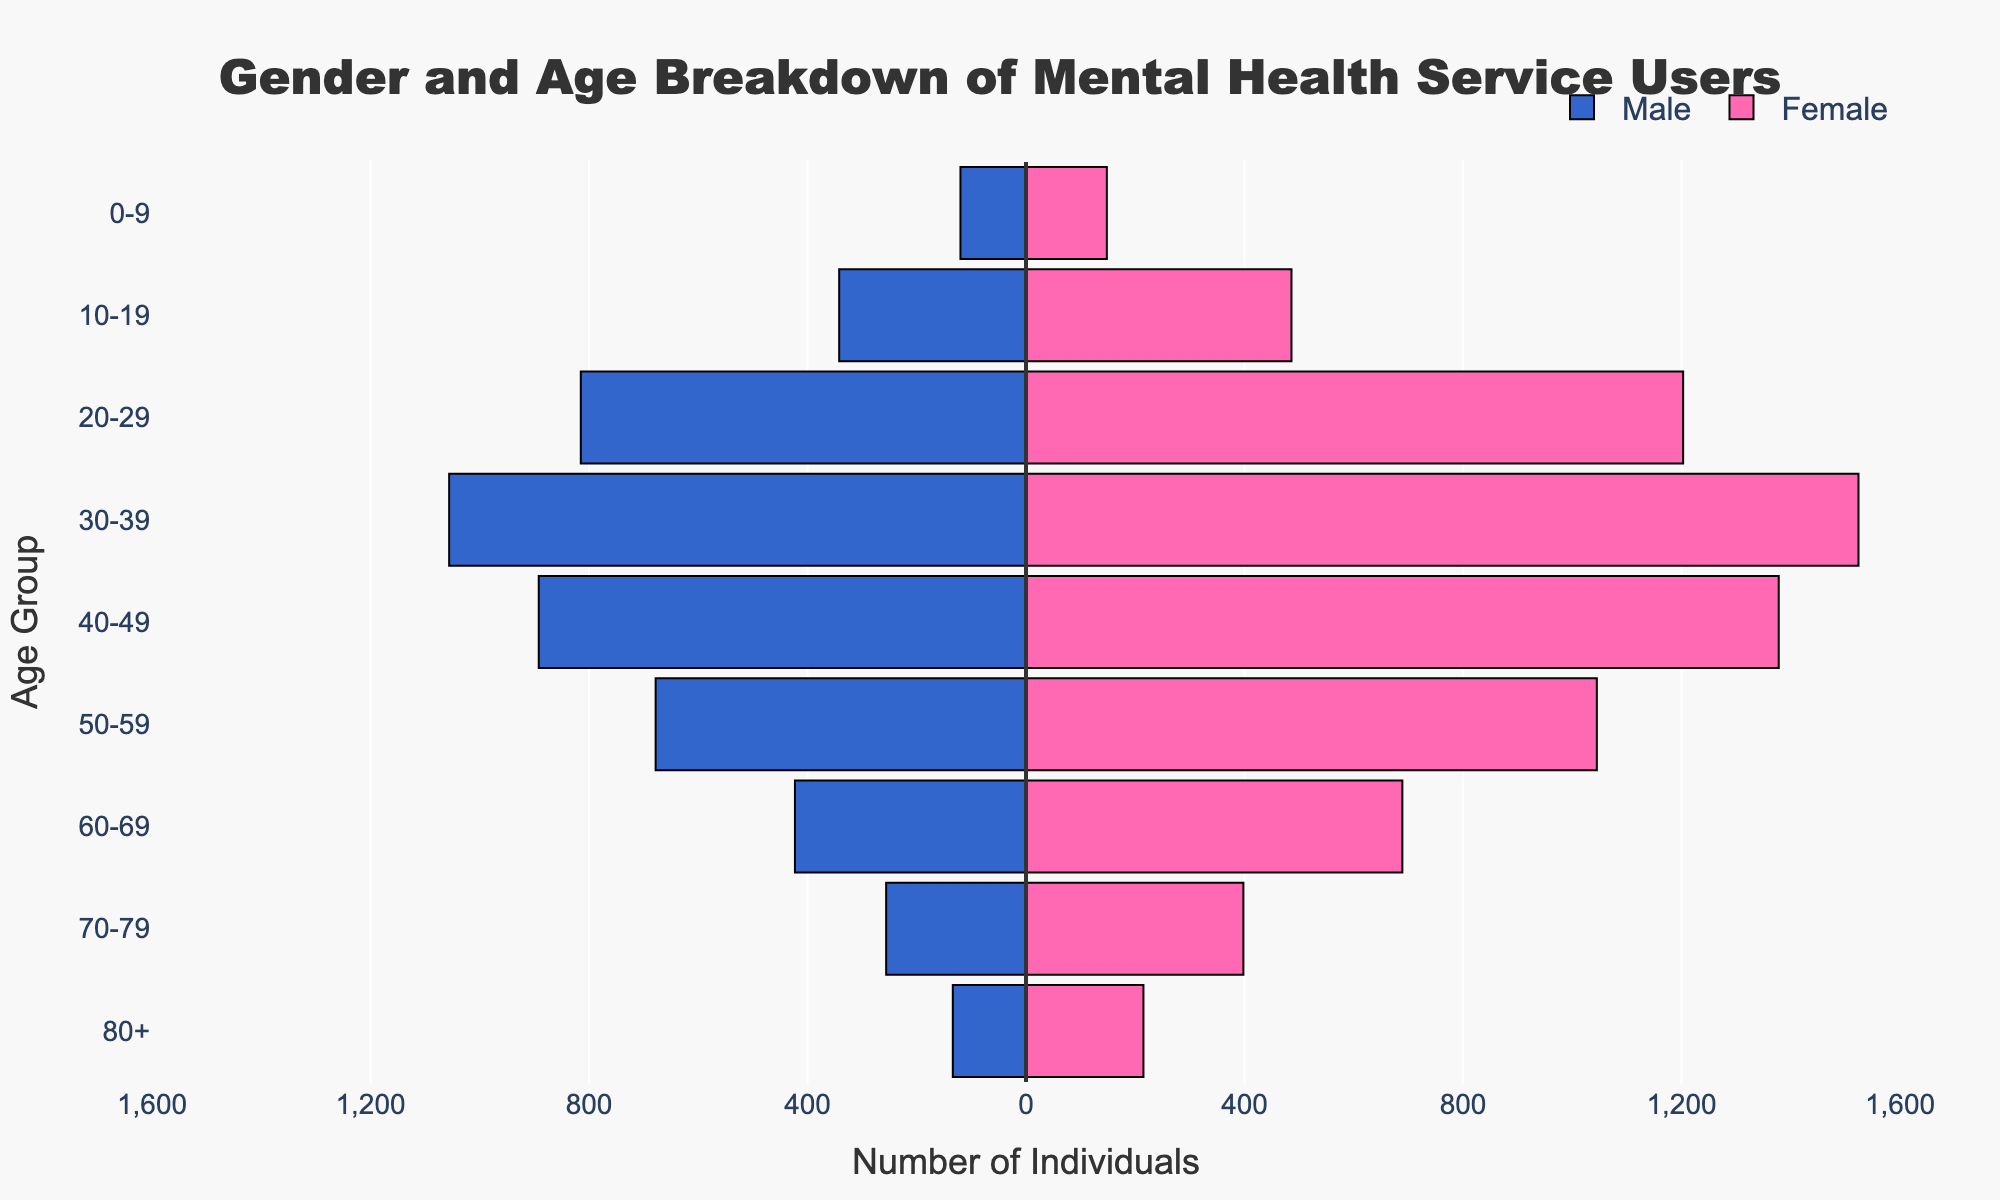What's the title of the figure? The title of the figure appears at the top of the plot. Simply reading it reveals the title.
Answer: Gender and Age Breakdown of Mental Health Service Users What are the colors used for male and female bars in the plot? By observing the bars, males are represented with a blue color, and females are shown with a pink color.
Answer: Blue for males, pink for females How many males in the 20-29 age group access mental health services? The bar representing males in the 20-29 age group extends to the left. Counting the negative value on the x-axis gives us the number of males.
Answer: 815 What age group has the highest number of female mental health service users? By comparing the lengths of the pink bars, the 30-39 age group has the longest bar, indicating the highest number of females.
Answer: 30-39 What is the total number of individuals aged 40-49 accessing mental health services? Summing up the values for males and females in the 40-49 age group: 892 (males) + 1378 (females) = 2270.
Answer: 2270 Are there more females than males accessing mental health services in the 50-59 age group? By comparing the bar lengths for males and females in the 50-59 age group, the female bar is longer.
Answer: Yes Which age group has the smallest gender disparity in accessing mental health services? Looking for bars with similar lengths for males and females, the 0-9 age group shows the smallest difference between the two.
Answer: 0-9 What is the combined total of males and females accessing mental health services across all age groups? Adding up the total values across all age groups for both males and females: (120+342+815+1056+892+678+423+256+134) for males + (148+486+1203+1524+1378+1045+689+398+215) for females = 4716 (males) + 7086 (females) = 11802.
Answer: 11802 In which age group do males have the highest representation in mental health services? Comparing the lengths of the blue bars, the 30-39 age group has the longest male bar.
Answer: 30-39 What is the average number of females accessing mental health services in the age groups between 20-49 (inclusive)? Summing the number of females in the 20-29, 30-39, and 40-49 age groups, then dividing by 3: (1203 + 1524 + 1378) / 3 = 4105 / 3 = 1368.33.
Answer: 1368.33 